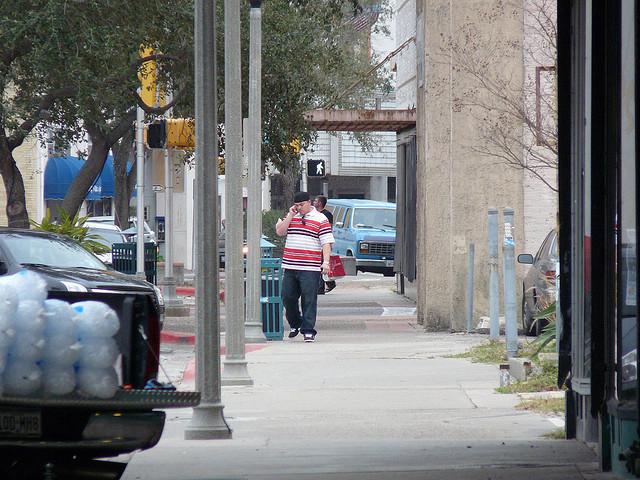What color is the van?
Keep it brief. Blue. Bags of what are in the truck bed?
Short answer required. Ice. Is the boy skinny?
Concise answer only. No. 